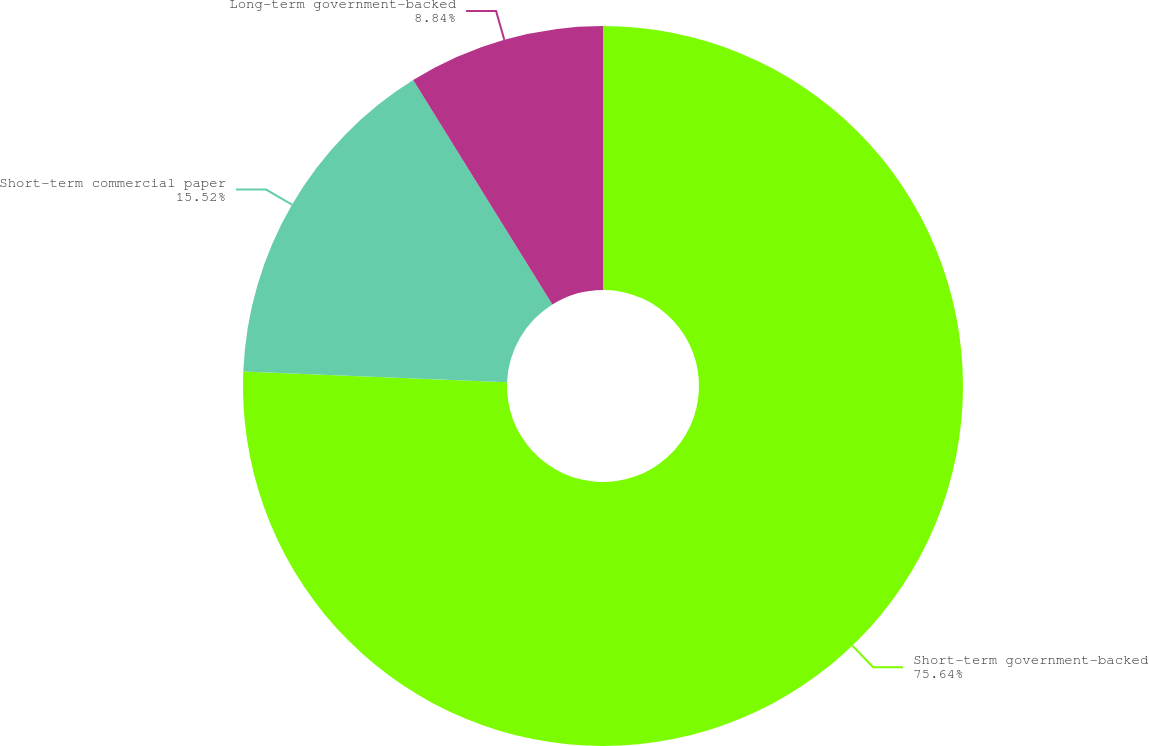Convert chart. <chart><loc_0><loc_0><loc_500><loc_500><pie_chart><fcel>Short-term government-backed<fcel>Short-term commercial paper<fcel>Long-term government-backed<nl><fcel>75.64%<fcel>15.52%<fcel>8.84%<nl></chart> 